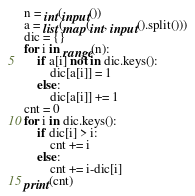<code> <loc_0><loc_0><loc_500><loc_500><_Python_>n = int(input())
a = list(map(int, input().split()))
dic = {}
for i in range(n):
    if a[i] not in dic.keys():
        dic[a[i]] = 1
    else:
        dic[a[i]] += 1
cnt = 0
for i in dic.keys():
    if dic[i] > i:
        cnt += i
    else:
        cnt += i-dic[i] 
print(cnt)</code> 